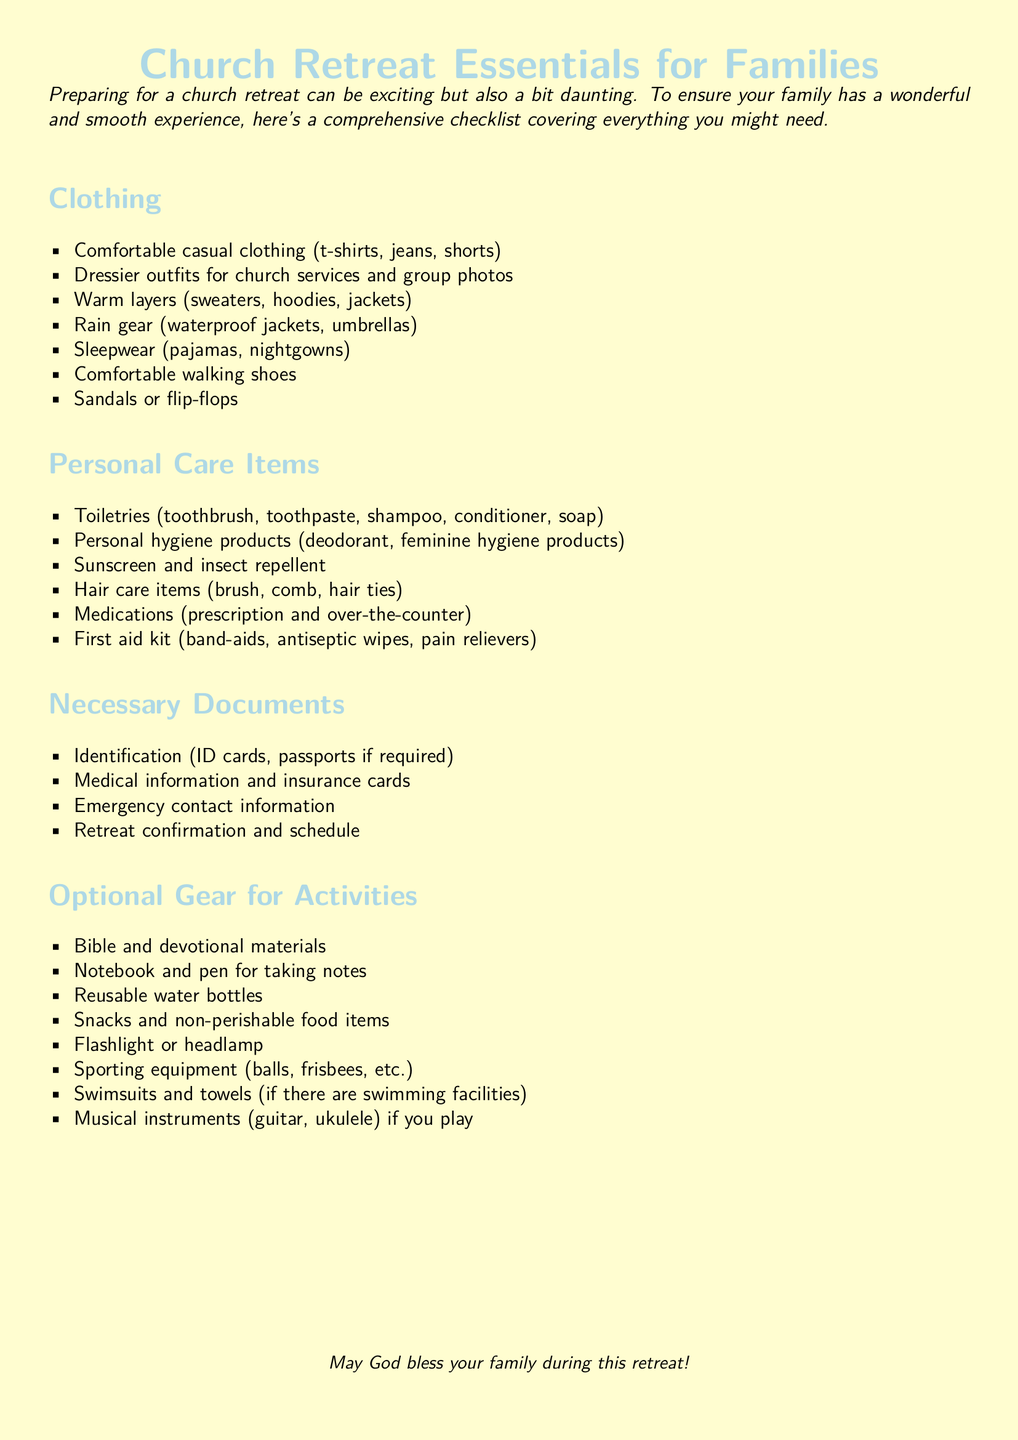What clothing items are recommended for the retreat? The document lists several categories of clothing, including warm layers, casual clothing, and dressier outfits.
Answer: Comfortable casual clothing, warm layers, dressier outfits How many personal care items are listed? The list under personal care items contains six different items that families should bring.
Answer: Six What should families bring for emergency contact information? The document specifies that families should include a specific piece of information related to emergencies.
Answer: Emergency contact information Which item is optional for activities? The document mentions several optional items, highlighting one related to the retreat activities.
Answer: Bible and devotional materials What is the color of the page background? The document uses a specific color for its page background that is visually distinct.
Answer: Pastelyellow What type of footwear is recommended for the retreat? The document mentions specific types of footwear highlighted under clothing.
Answer: Comfortable walking shoes, Sandals or flip-flops What should families include regarding medications? The document specifies a critical category that families should ensure to bring for health reasons.
Answer: Medications (prescription and over-the-counter) What item is suggested if swimming facilities are available? The document lists specific gear that would be suitable for water activities.
Answer: Swimsuits and towels 